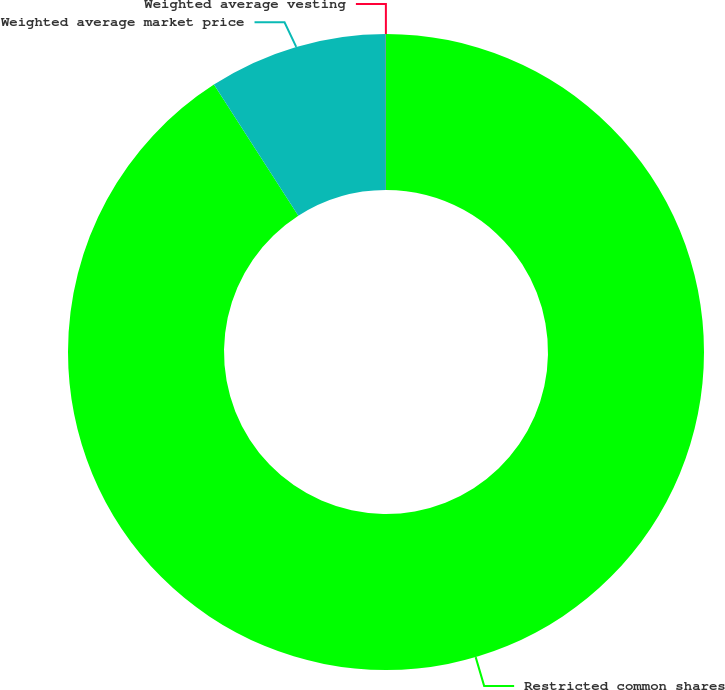<chart> <loc_0><loc_0><loc_500><loc_500><pie_chart><fcel>Restricted common shares<fcel>Weighted average market price<fcel>Weighted average vesting<nl><fcel>90.9%<fcel>9.09%<fcel>0.01%<nl></chart> 